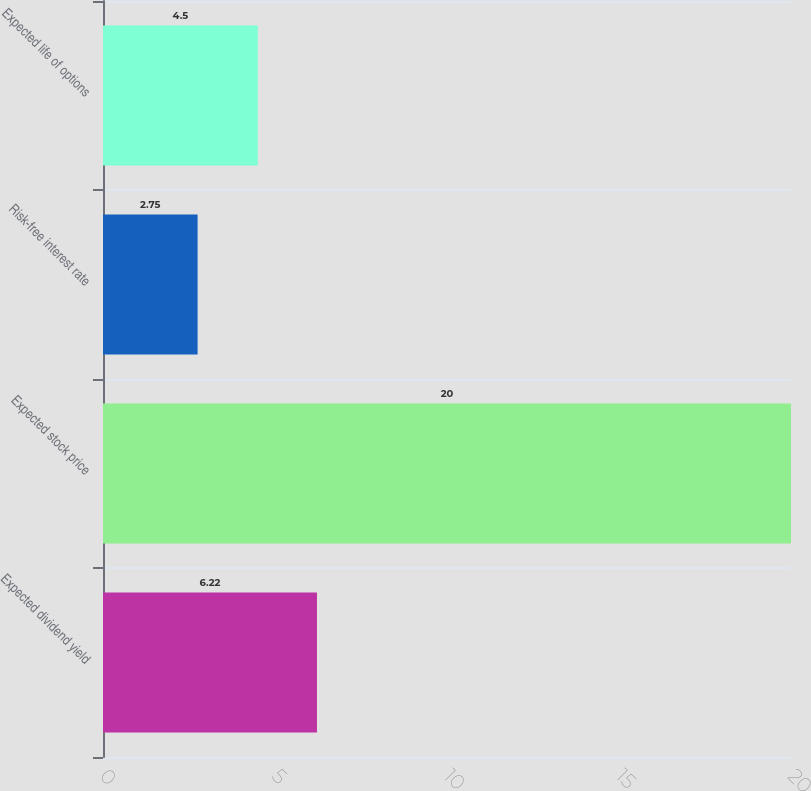<chart> <loc_0><loc_0><loc_500><loc_500><bar_chart><fcel>Expected dividend yield<fcel>Expected stock price<fcel>Risk-free interest rate<fcel>Expected life of options<nl><fcel>6.22<fcel>20<fcel>2.75<fcel>4.5<nl></chart> 